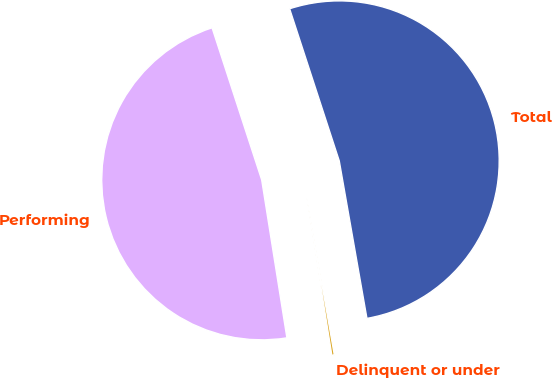<chart> <loc_0><loc_0><loc_500><loc_500><pie_chart><fcel>Performing<fcel>Delinquent or under<fcel>Total<nl><fcel>47.5%<fcel>0.25%<fcel>52.25%<nl></chart> 